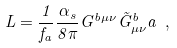<formula> <loc_0><loc_0><loc_500><loc_500>L = \frac { 1 } { f _ { a } } \frac { \alpha _ { s } } { 8 \pi } G ^ { b \mu \nu } { \tilde { G } } ^ { b } _ { \mu \nu } a \ ,</formula> 